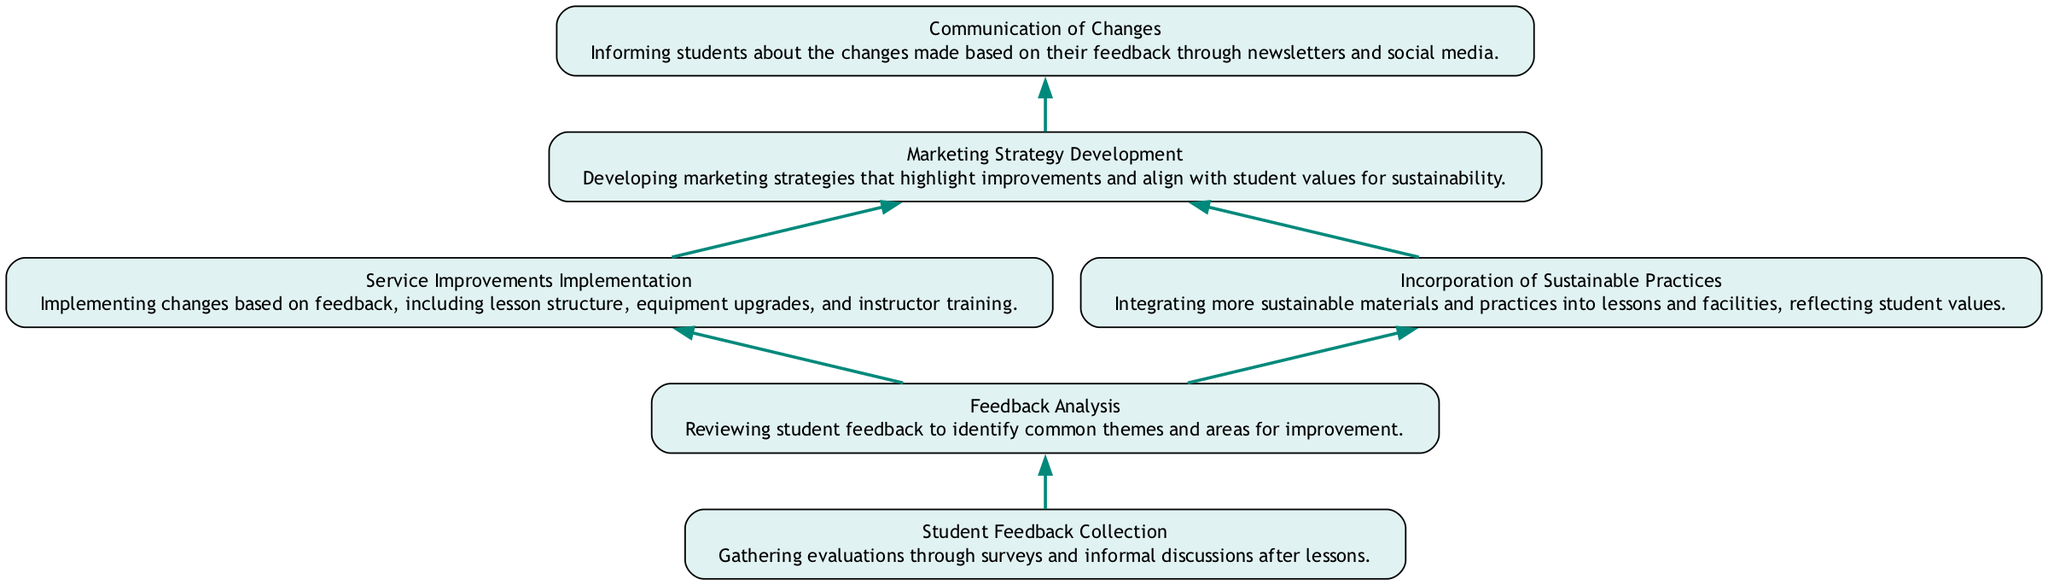What is the first step in the feedback flow? The first step in the feedback flow is "Student Feedback Collection," which is indicated as the starting node in the diagram.
Answer: Student Feedback Collection How many nodes are there in the diagram? By counting each distinct labeled box in the diagram, we find there are six unique nodes present in the "Bottom Up Flow Chart."
Answer: 6 What is the relationship between "Feedback Analysis" and "Service Improvements Implementation"? The diagram shows a direct flow from "Feedback Analysis" to "Service Improvements Implementation," indicating that feedback is analyzed before implementing any service improvements.
Answer: Feedback Analysis → Service Improvements Implementation What is implemented based on student feedback? The node "Service Improvements Implementation" describes that various changes such as lesson structure, equipment upgrades, and instructor training are made based on student feedback.
Answer: Changes in lesson structure, equipment upgrades, instructor training Which nodes point to the "Marketing Strategy Development"? Both "Service Improvements Implementation" and "Incorporation of Sustainable Practices" point to "Marketing Strategy Development," indicating that both aspects contribute to developing marketing strategies.
Answer: Service Improvements Implementation, Incorporation of Sustainable Practices How is communication about changes made to students? The final step in the process, "Communication of Changes," indicates that students are informed about changes made through newsletters and social media.
Answer: Newsletters and social media Why is "Incorporation of Sustainable Practices" important in this flow? This node is important because it reflects student values on sustainability, which subsequently influences the marketing strategy, helping align the services with student preferences.
Answer: Student values on sustainability What is the last step in the flow chart? The last step is "Communication of Changes," which indicates the end of the flow where students are informed about the improvements made based on their feedback.
Answer: Communication of Changes 